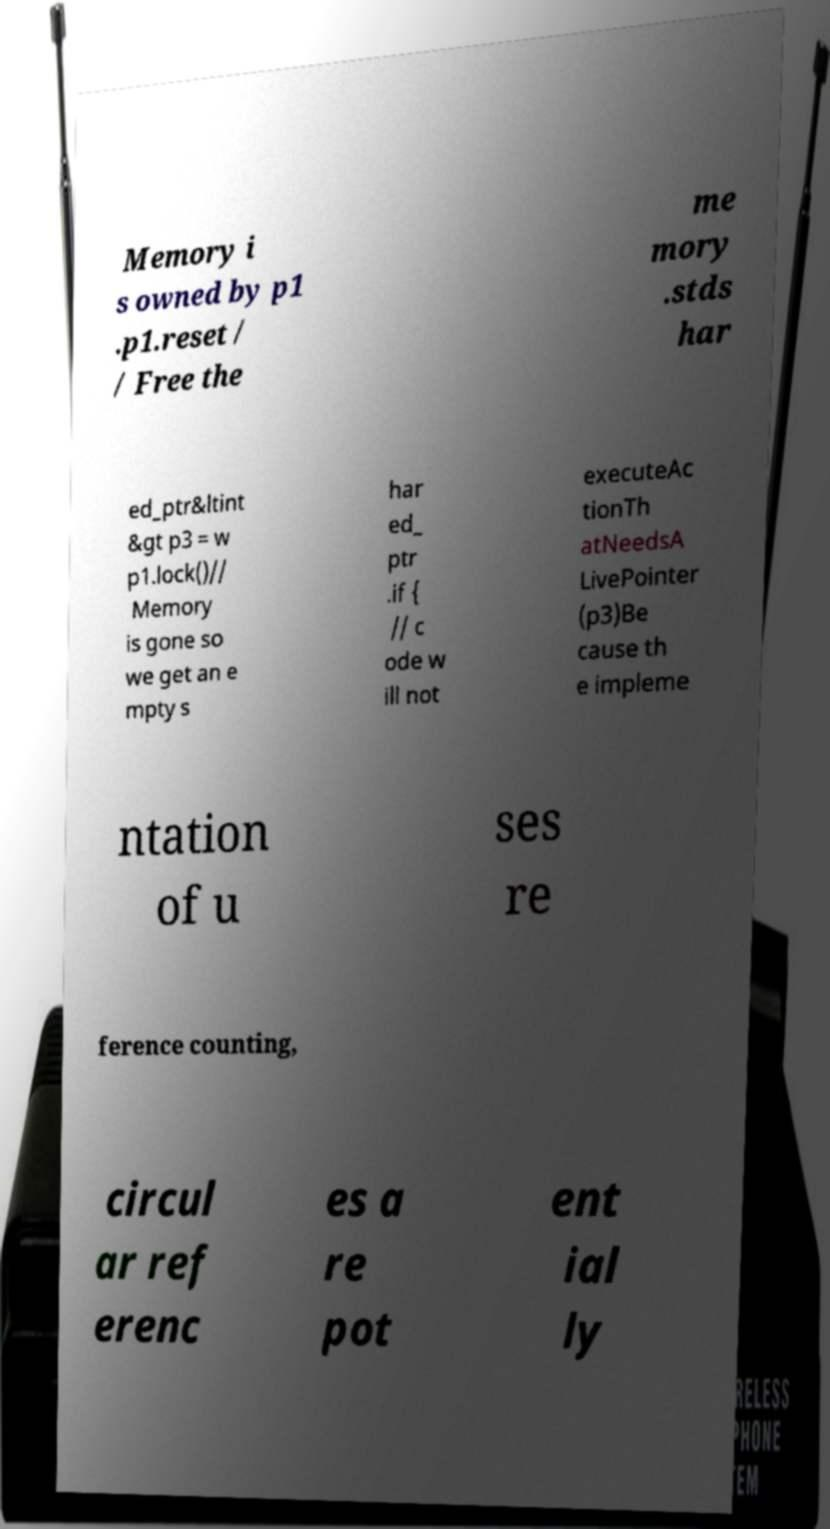I need the written content from this picture converted into text. Can you do that? Memory i s owned by p1 .p1.reset / / Free the me mory .stds har ed_ptr&ltint &gt p3 = w p1.lock()// Memory is gone so we get an e mpty s har ed_ ptr .if { // c ode w ill not executeAc tionTh atNeedsA LivePointer (p3)Be cause th e impleme ntation of u ses re ference counting, circul ar ref erenc es a re pot ent ial ly 